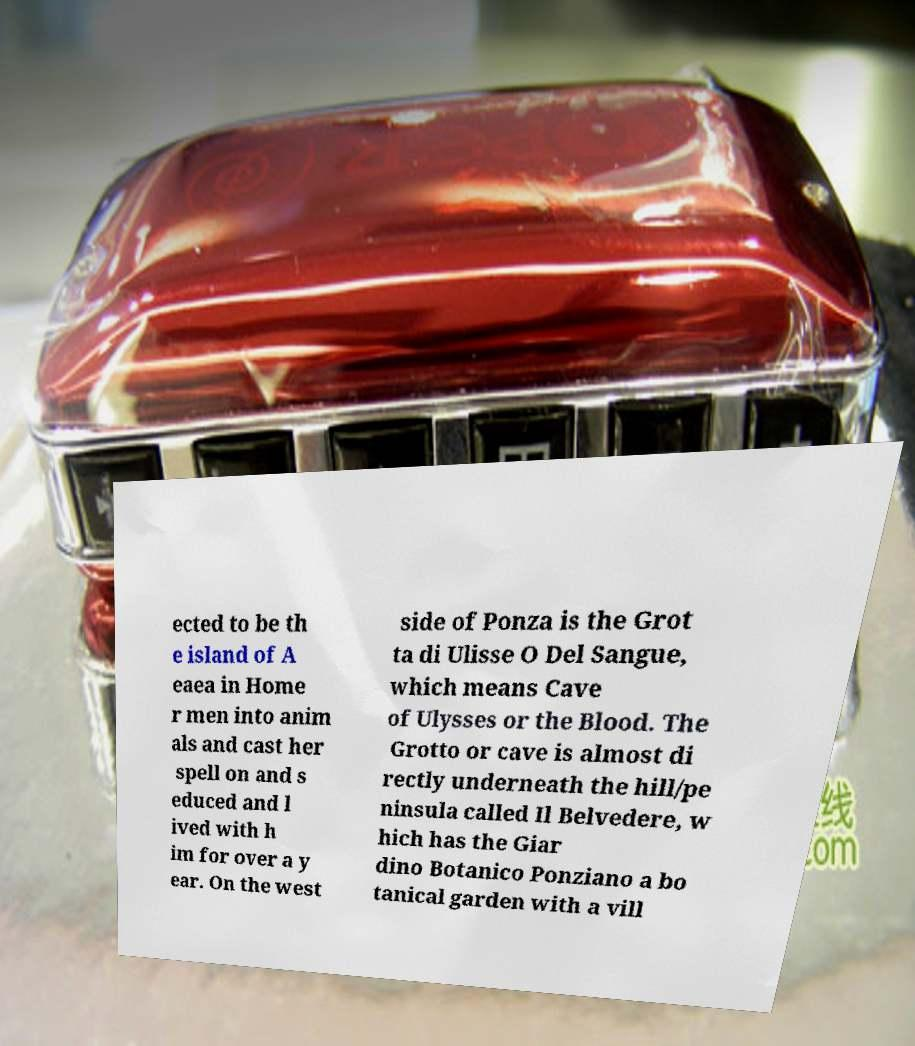Please read and relay the text visible in this image. What does it say? ected to be th e island of A eaea in Home r men into anim als and cast her spell on and s educed and l ived with h im for over a y ear. On the west side of Ponza is the Grot ta di Ulisse O Del Sangue, which means Cave of Ulysses or the Blood. The Grotto or cave is almost di rectly underneath the hill/pe ninsula called Il Belvedere, w hich has the Giar dino Botanico Ponziano a bo tanical garden with a vill 